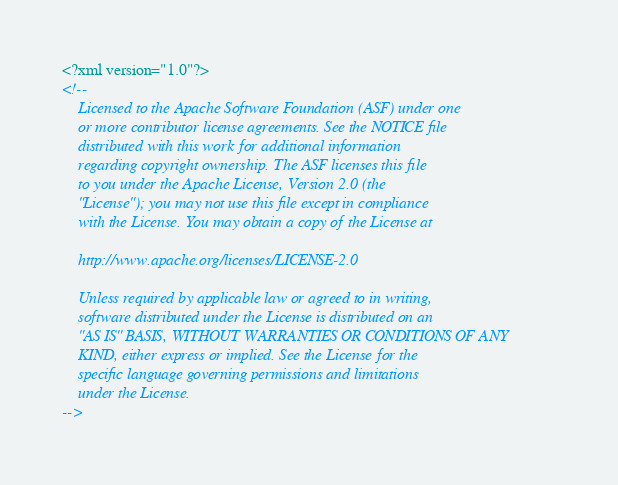Convert code to text. <code><loc_0><loc_0><loc_500><loc_500><_XML_><?xml version="1.0"?>
<!--
    Licensed to the Apache Software Foundation (ASF) under one
    or more contributor license agreements. See the NOTICE file
    distributed with this work for additional information
    regarding copyright ownership. The ASF licenses this file
    to you under the Apache License, Version 2.0 (the
    "License"); you may not use this file except in compliance
    with the License. You may obtain a copy of the License at
    
    http://www.apache.org/licenses/LICENSE-2.0
    
    Unless required by applicable law or agreed to in writing,
    software distributed under the License is distributed on an
    "AS IS" BASIS, WITHOUT WARRANTIES OR CONDITIONS OF ANY
    KIND, either express or implied. See the License for the
    specific language governing permissions and limitations
    under the License.
--></code> 